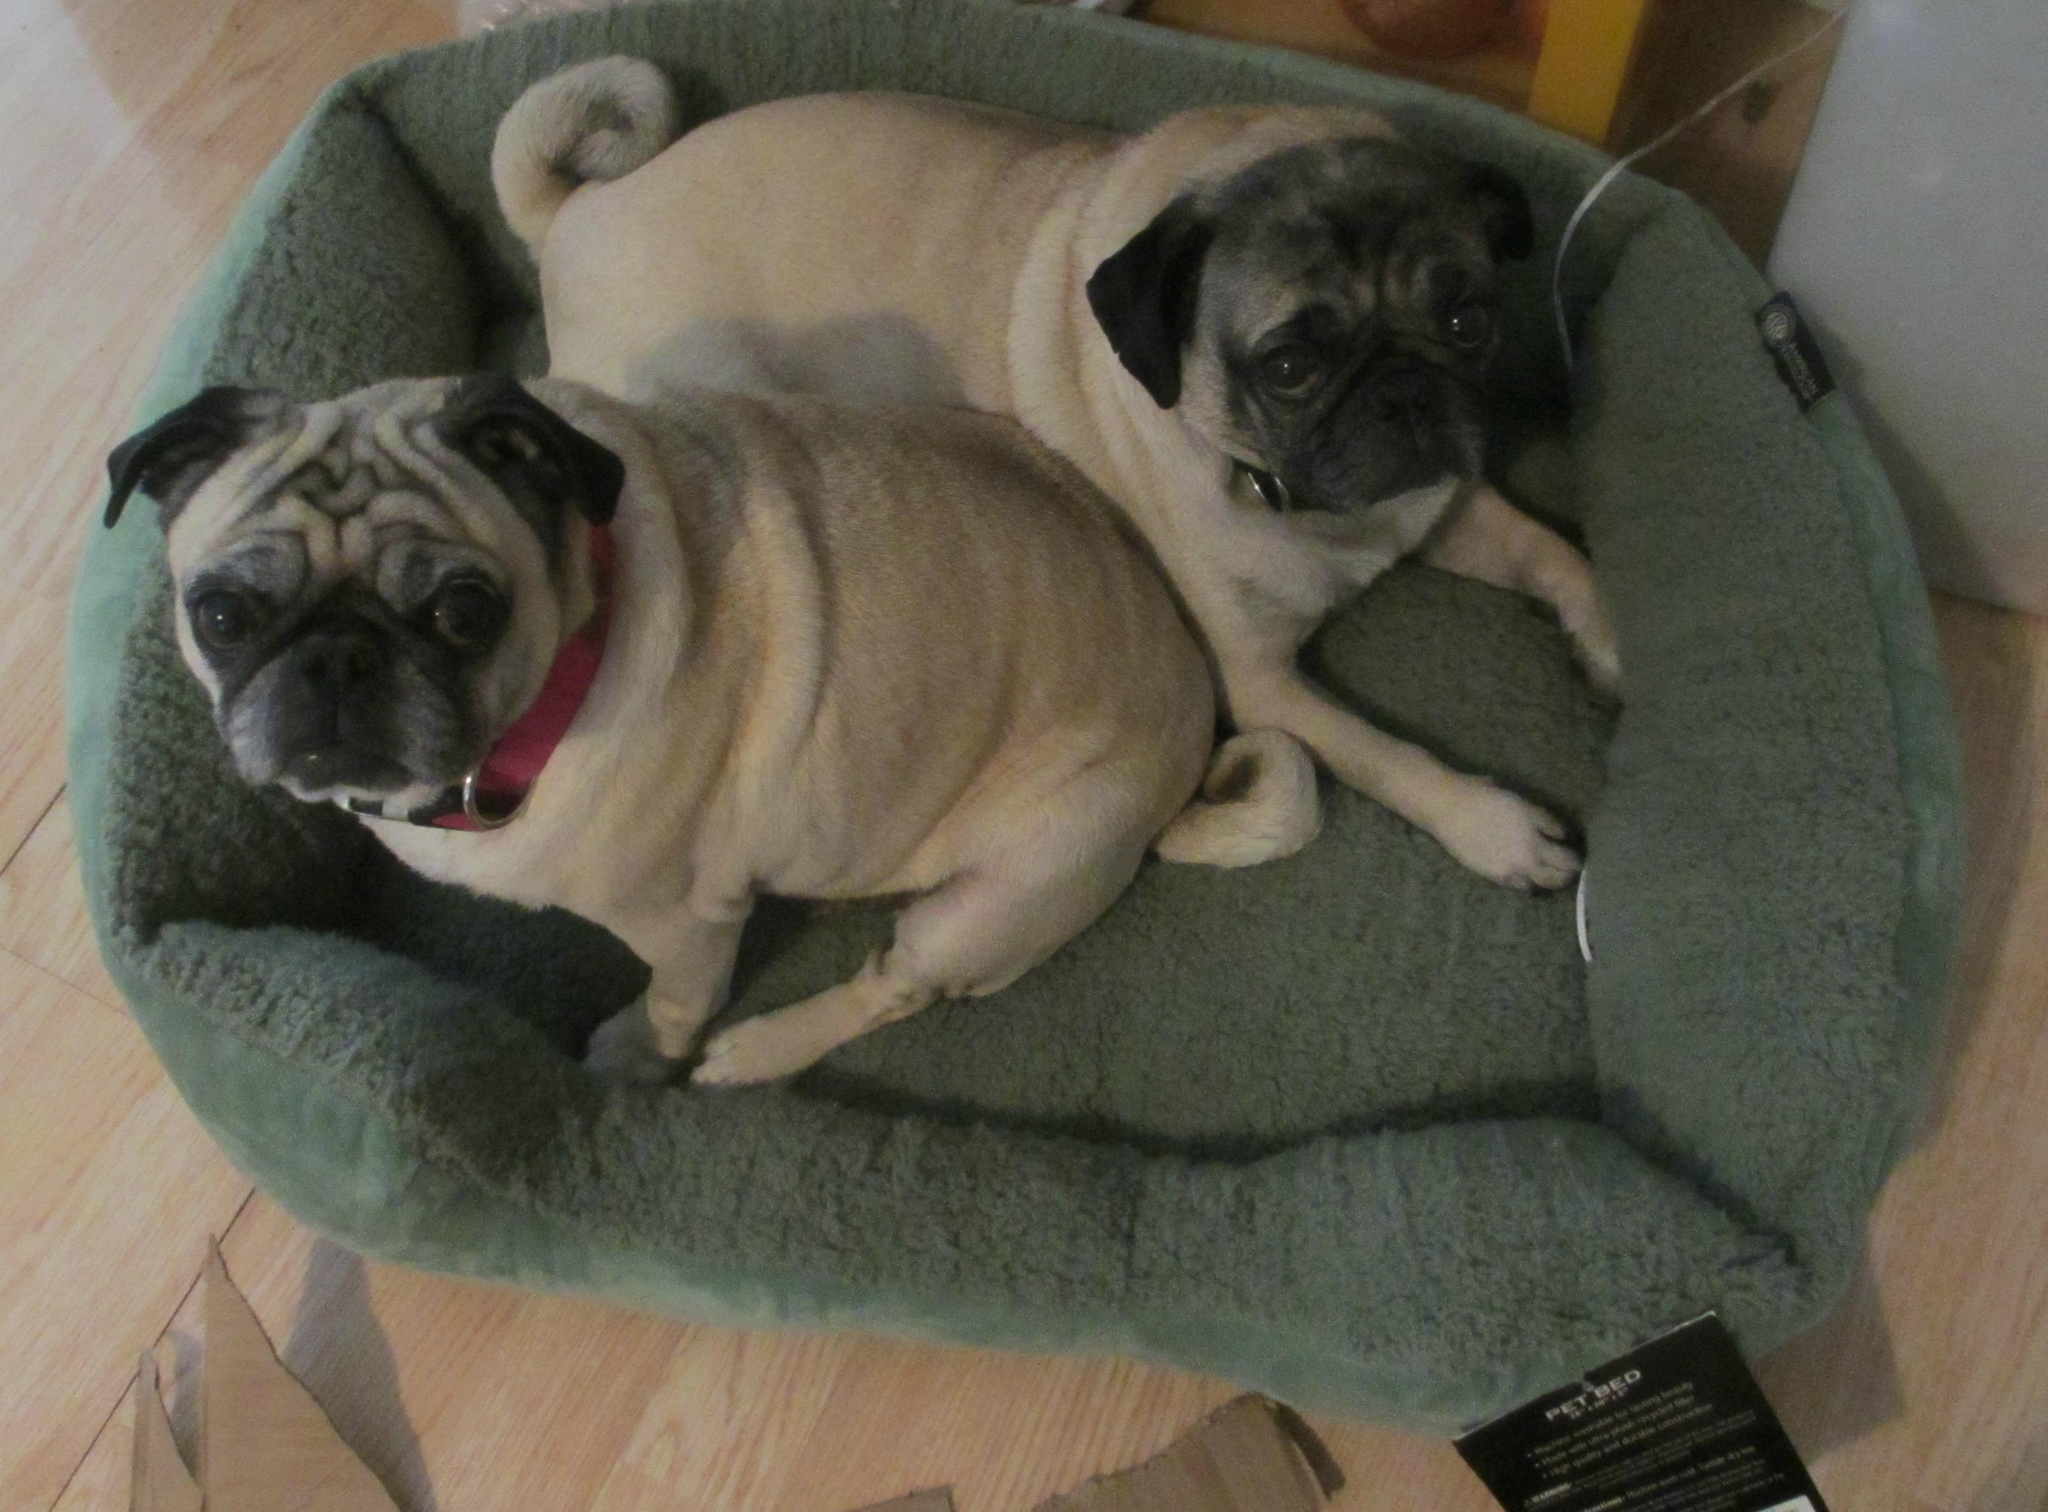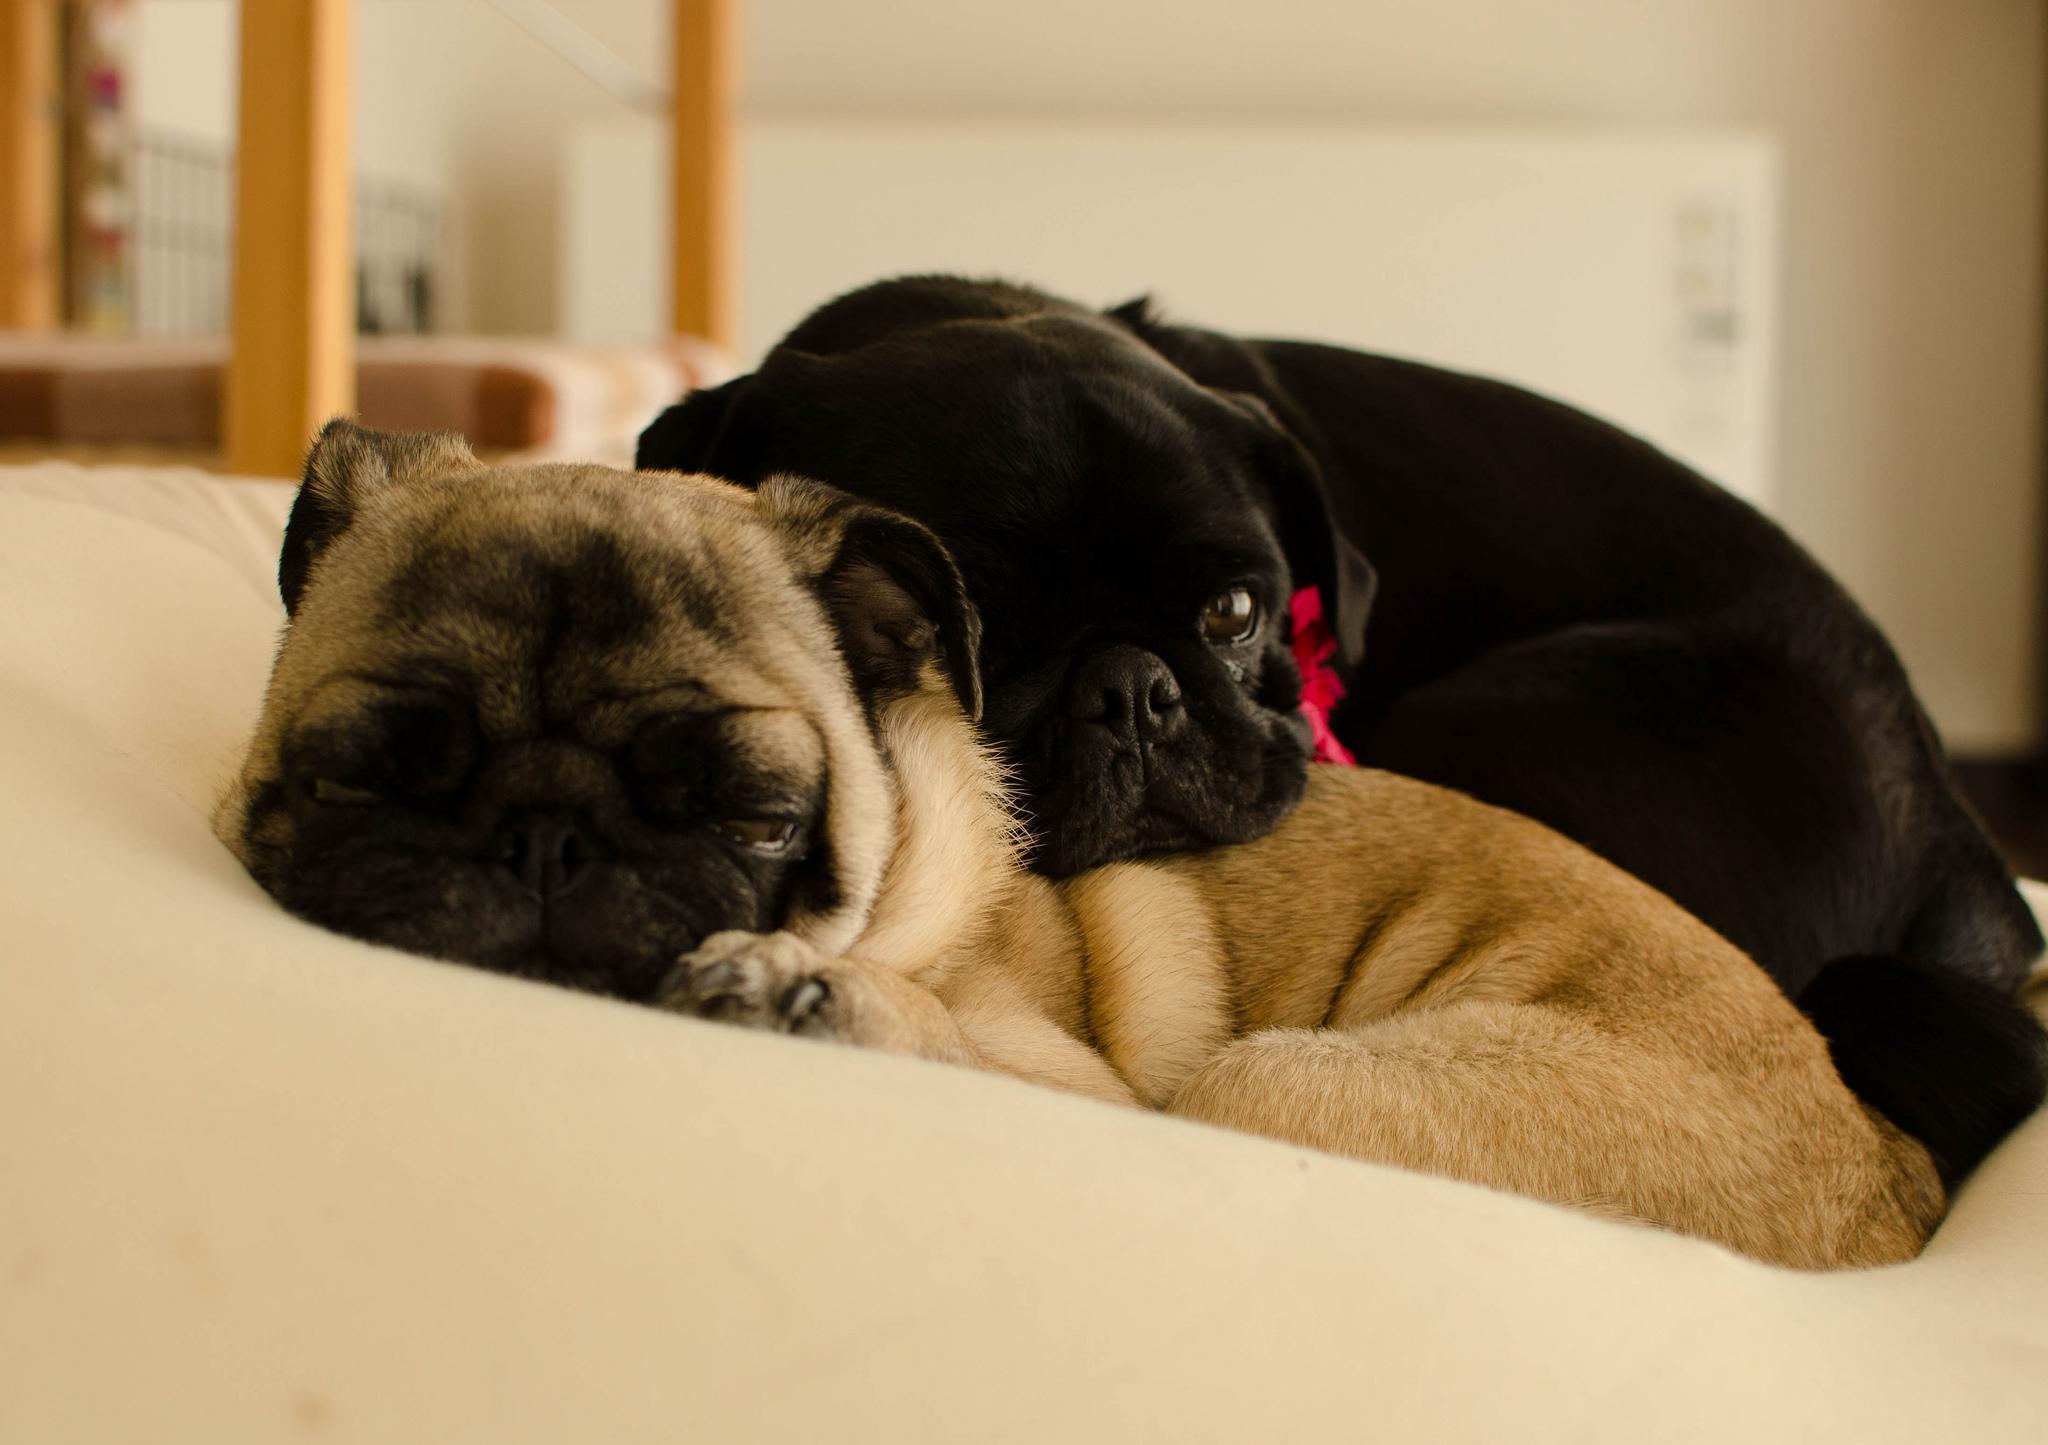The first image is the image on the left, the second image is the image on the right. Given the left and right images, does the statement "The left image contains one black dog laying next to one tan dog." hold true? Answer yes or no. No. The first image is the image on the left, the second image is the image on the right. For the images shown, is this caption "Two camel-colored pugs relax together on a soft surface, with one posed above the other one." true? Answer yes or no. Yes. 